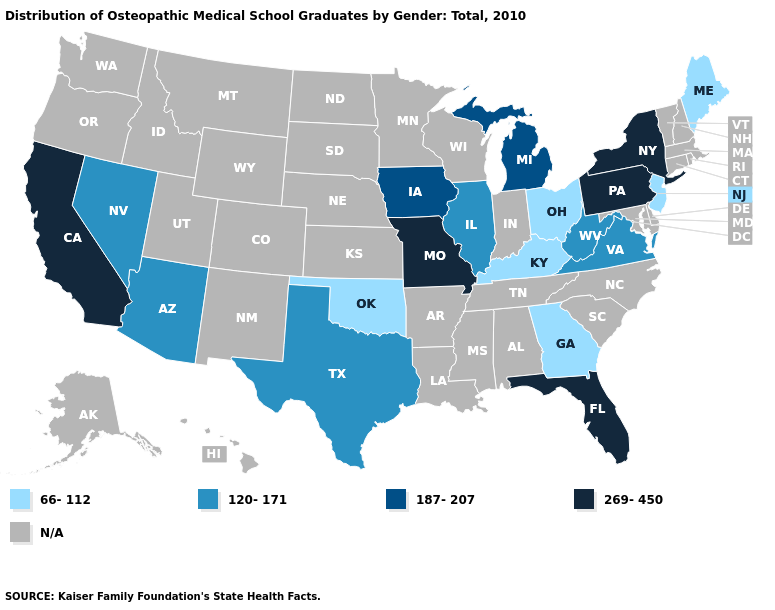What is the value of Oklahoma?
Concise answer only. 66-112. Does Florida have the highest value in the USA?
Answer briefly. Yes. Is the legend a continuous bar?
Write a very short answer. No. What is the lowest value in states that border Florida?
Keep it brief. 66-112. What is the value of Ohio?
Concise answer only. 66-112. Name the states that have a value in the range 269-450?
Short answer required. California, Florida, Missouri, New York, Pennsylvania. What is the value of Rhode Island?
Write a very short answer. N/A. What is the highest value in the MidWest ?
Answer briefly. 269-450. Does Texas have the lowest value in the USA?
Keep it brief. No. What is the value of New Mexico?
Keep it brief. N/A. Is the legend a continuous bar?
Be succinct. No. What is the lowest value in the South?
Be succinct. 66-112. 